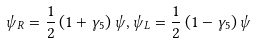<formula> <loc_0><loc_0><loc_500><loc_500>\psi _ { R } = \frac { 1 } { 2 } \left ( 1 + \gamma _ { 5 } \right ) \psi , \psi _ { L } = \frac { 1 } { 2 } \left ( 1 - \gamma _ { 5 } \right ) \psi</formula> 